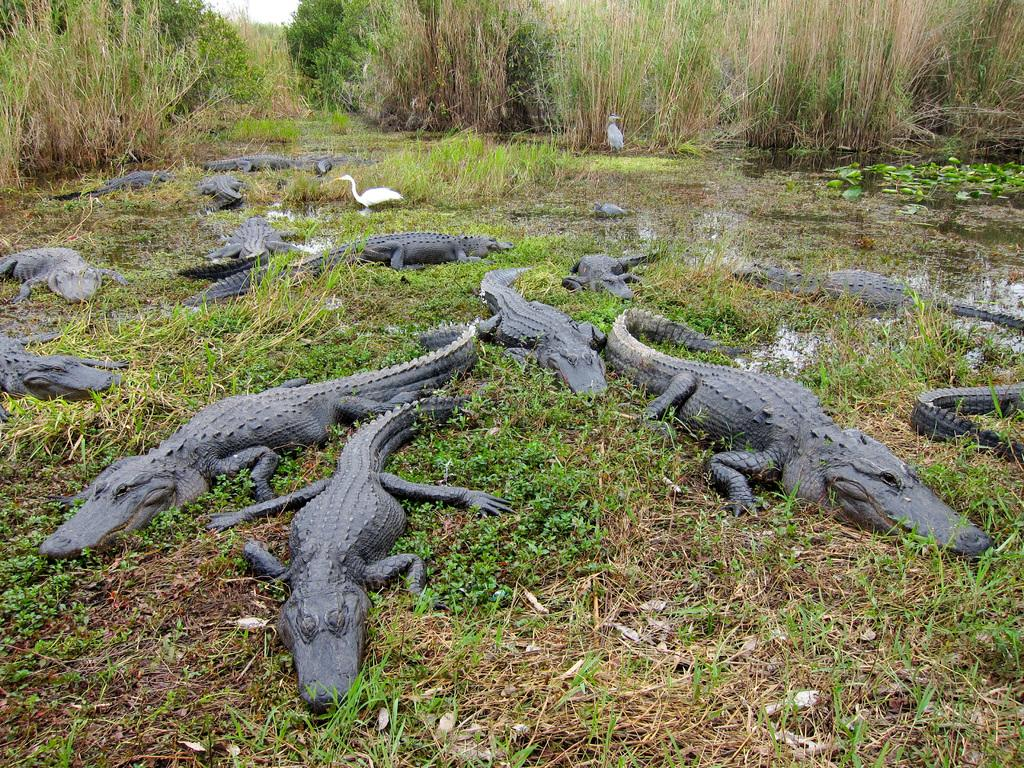What type of animals can be seen in the image? There are crocodiles and ducks in the image. What type of vegetation is present in the image? There are plants and trees in the image. What is the primary element visible in the image? There is water visible in the image. What part of the natural environment is visible in the image? The sky is visible in the image. What type of committee can be seen in the image? There is no committee present in the image. 